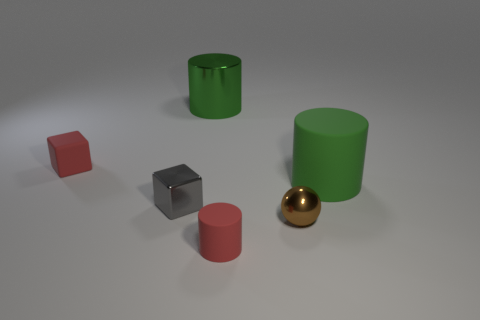Is there a large gray ball that has the same material as the tiny ball?
Offer a terse response. No. There is a red matte object that is on the right side of the red block; are there any brown shiny spheres in front of it?
Keep it short and to the point. No. Does the matte cylinder that is in front of the green matte cylinder have the same size as the tiny gray cube?
Your response must be concise. Yes. What size is the gray cube?
Ensure brevity in your answer.  Small. Are there any matte cylinders of the same color as the small metal cube?
Provide a succinct answer. No. What number of tiny objects are either brown things or matte cylinders?
Give a very brief answer. 2. What is the size of the thing that is both on the left side of the green matte thing and on the right side of the small rubber cylinder?
Your answer should be compact. Small. There is a large metal cylinder; how many metallic balls are in front of it?
Your answer should be compact. 1. What shape is the tiny object that is right of the shiny cube and left of the tiny brown sphere?
Your answer should be very brief. Cylinder. There is a block that is the same color as the small rubber cylinder; what material is it?
Provide a short and direct response. Rubber. 